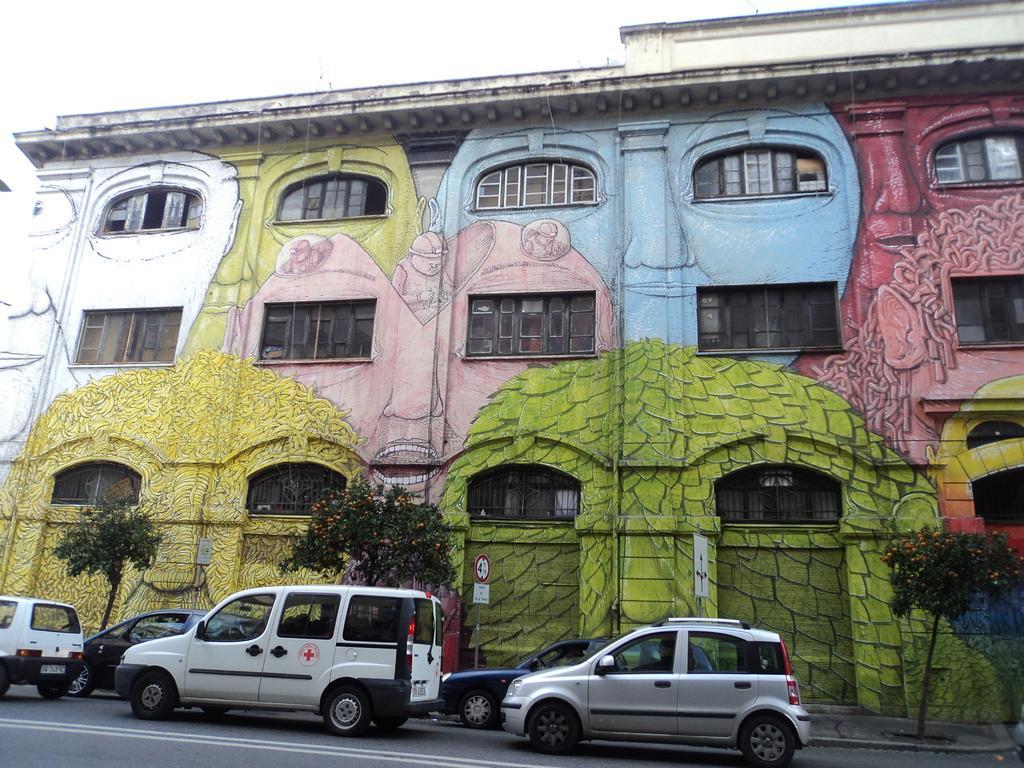Describe this image in one or two sentences. In this image I can see the vehicles on the road. To the side there are trees and the boards. In the background there is a building with windows and it is colorful. There is a sky in the back. 